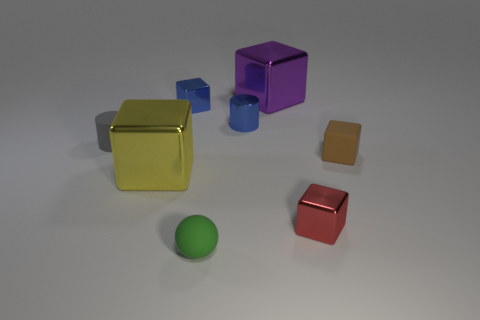Subtract all yellow cubes. How many cubes are left? 4 Subtract all tiny red cubes. How many cubes are left? 4 Add 1 big red metal balls. How many objects exist? 9 Subtract all red cubes. Subtract all cyan balls. How many cubes are left? 4 Subtract all blocks. How many objects are left? 3 Subtract 0 red cylinders. How many objects are left? 8 Subtract all large shiny objects. Subtract all small metal objects. How many objects are left? 3 Add 2 tiny metallic cubes. How many tiny metallic cubes are left? 4 Add 2 big metallic things. How many big metallic things exist? 4 